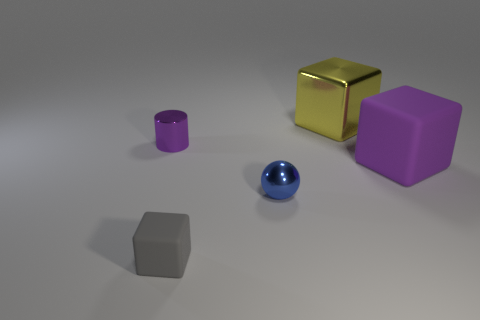Add 5 purple objects. How many objects exist? 10 Subtract all cylinders. How many objects are left? 4 Subtract 1 purple cylinders. How many objects are left? 4 Subtract all blue matte blocks. Subtract all tiny balls. How many objects are left? 4 Add 4 big yellow shiny objects. How many big yellow shiny objects are left? 5 Add 2 tiny brown rubber cylinders. How many tiny brown rubber cylinders exist? 2 